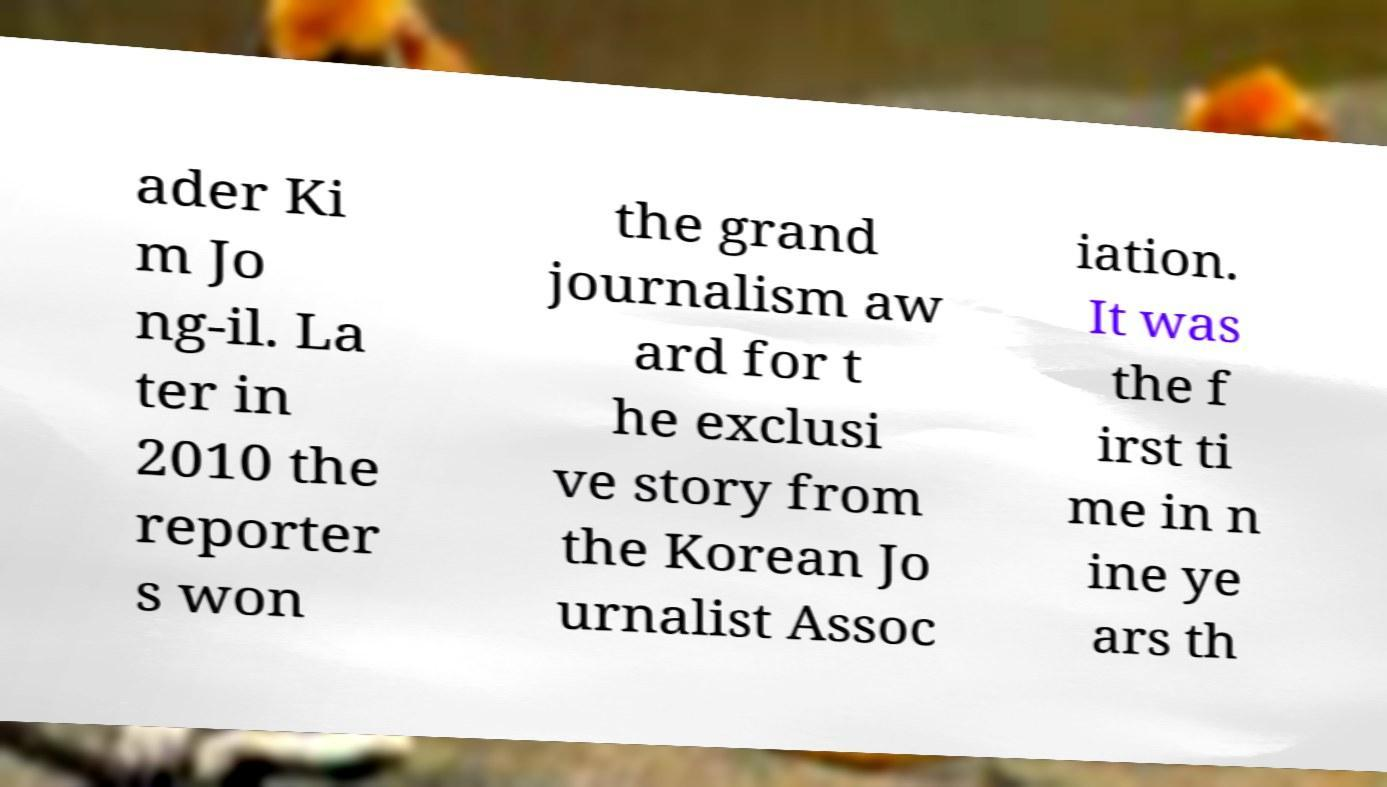Please read and relay the text visible in this image. What does it say? ader Ki m Jo ng-il. La ter in 2010 the reporter s won the grand journalism aw ard for t he exclusi ve story from the Korean Jo urnalist Assoc iation. It was the f irst ti me in n ine ye ars th 